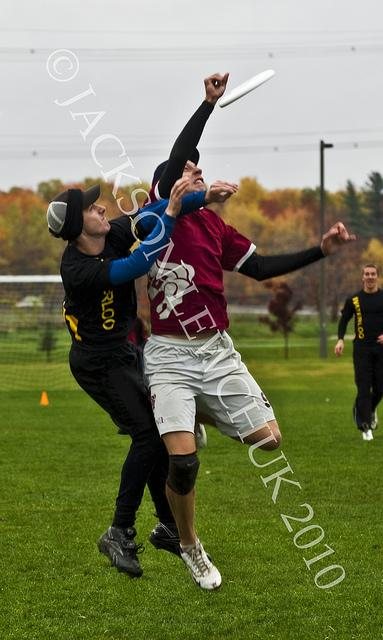What might stop you from using this image in a commercial capacity? Please explain your reasoning. watermark. It would be unprofessional to display this image in a publication with the watermark on it because viewers would know you did not have permission to use the image. 